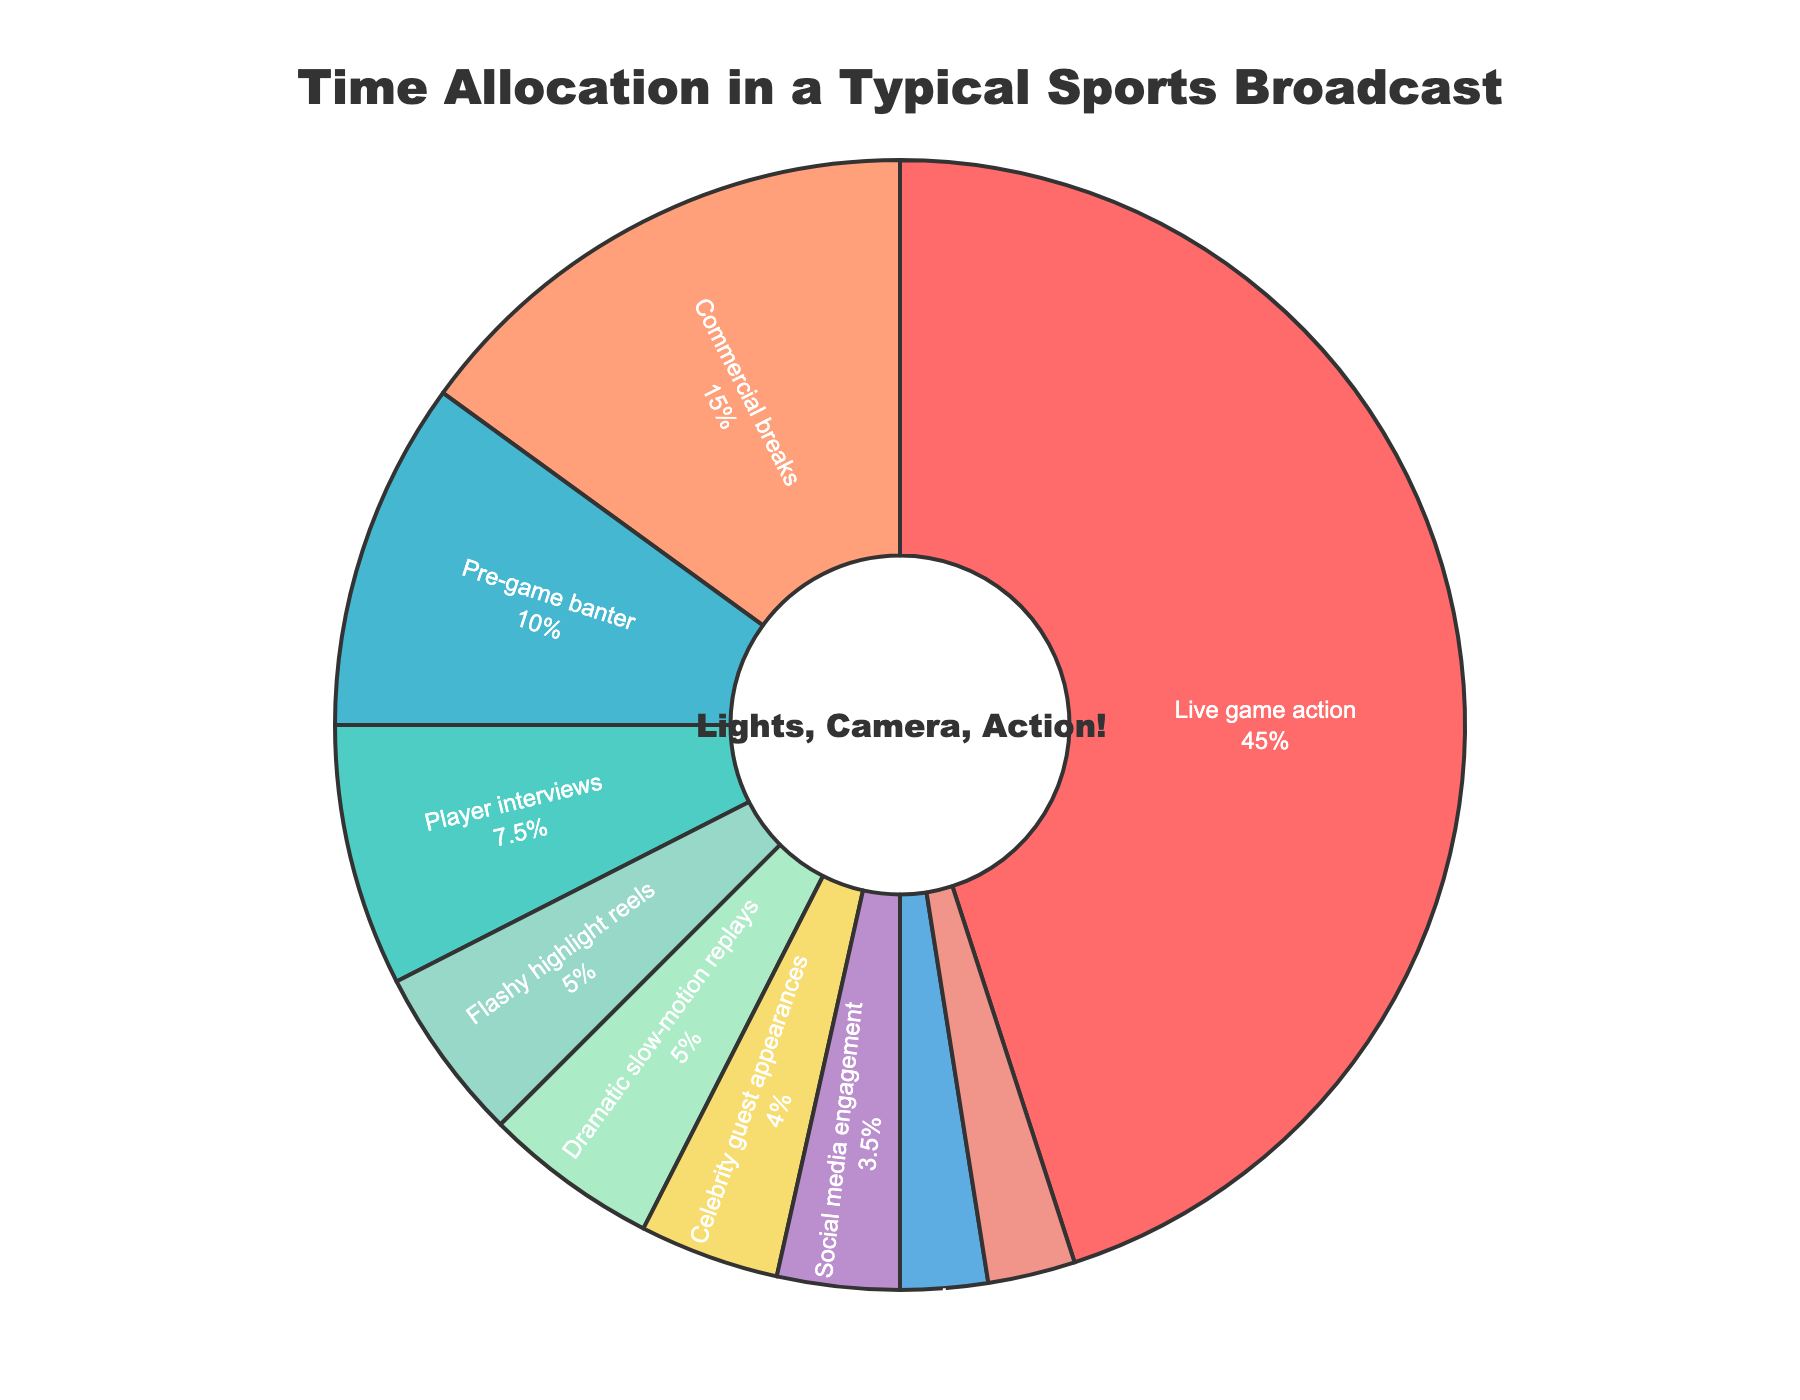Which segment takes up the largest portion of the sports broadcast? The segment with the largest portion will have the biggest slice in the pie chart. The "Live game action" slice is the largest.
Answer: Live game action How much total time is spent on segments involving game action and its highlights? Add the time for "Live game action" and "Flashy highlight reels." The times are 90 and 10 minutes respectively. Therefore, 90 + 10 = 100 minutes.
Answer: 100 minutes Which segment takes up more time, commercial breaks or pre-game banter? Look at the sizes of the slices for "Commercial breaks" and "Pre-game banter." The "Commercial breaks" slice is bigger.
Answer: Commercial breaks What is the combined percentage of time spent on social media engagement and witty one-liners and jokes? Add the percentages of both segments. Social media engagement is 3.5% and witty one-liners and jokes are 2.5%. Therefore, 3.5% + 2.5% = 6%.
Answer: 6% Which segments take up less than 10 minutes of the broadcast? Look for slices that correspond to less than 10 minutes. "Social media engagement," "Cheerleader spotlights," and "Witty one-liners and jokes" each take up 7, 5, and 5 minutes respectively.
Answer: Social media engagement, Cheerleader spotlights, Witty one-liners and jokes Are player interviews allocated more time than flashy highlight reels? Compare the sizes of the "Player interviews" and "Flashy highlight reels" slices. The "Player interviews" slice is larger.
Answer: Yes What is the difference in time allocation between celebrity guest appearances and cheerleader spotlights? Subtract the time for "Cheerleader spotlights" from "Celebrity guest appearances." 8 - 5 = 3 minutes.
Answer: 3 minutes Which segment has the smallest share of the broadcast? The smallest slice in the pie chart represents the smallest share. The "Witty one-liners and jokes" and "Cheerleader spotlights" both have the smallest slices.
Answer: Witty one-liners and jokes, Cheerleader spotlights How many segments take up more than 20 minutes each? Identify the segments with slices greater than 20 minutes: "Live game action" at 90 minutes.
Answer: 1 segment 